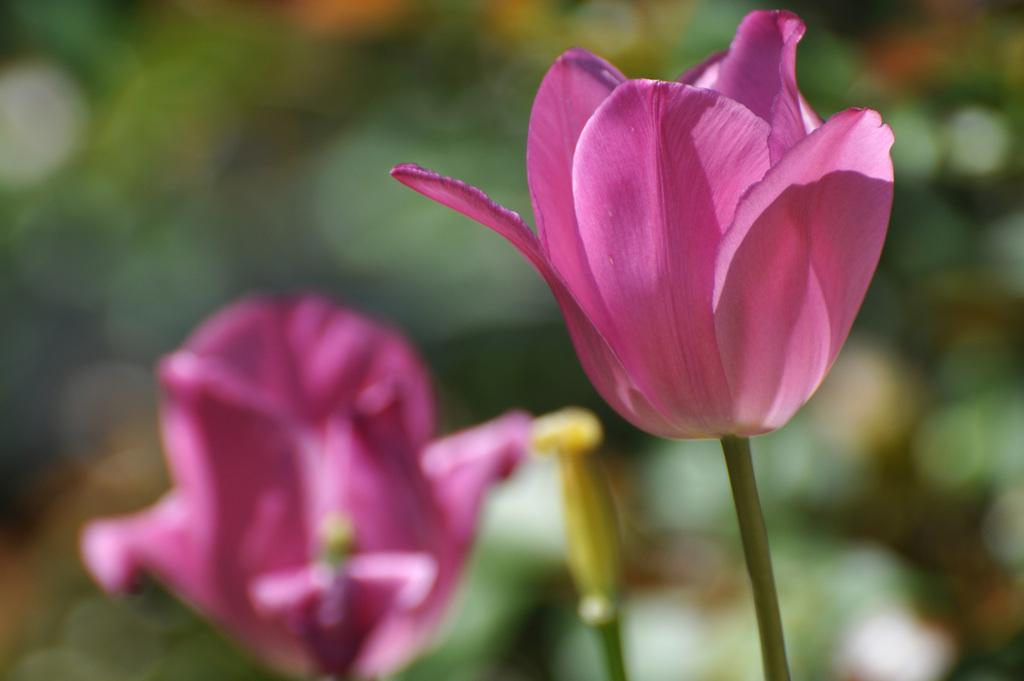How many flowers are present in the image? There are 2 pink color flowers in the image. Where are the flowers located in the image? The flowers are in the front of the image. What can be observed about the background of the image? The background of the image is blurred. How many passengers are visible in the image? There are no passengers present in the image; it features 2 pink color flowers in the front with a blurred background. 